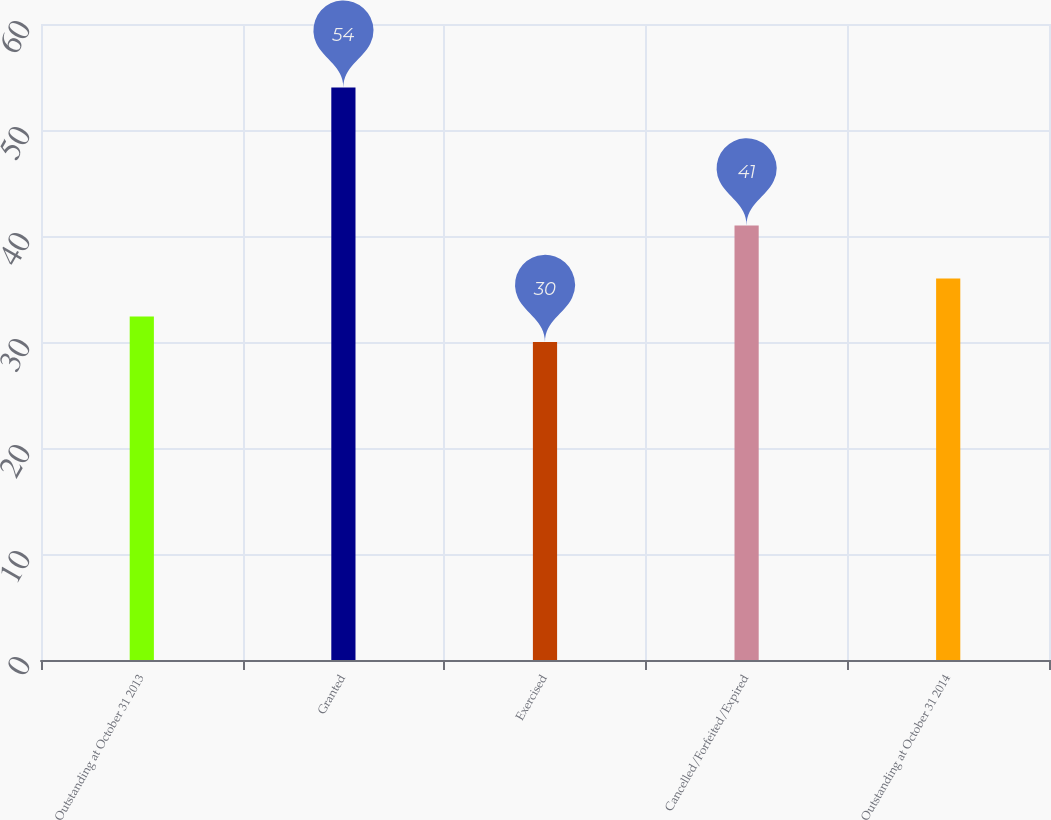Convert chart to OTSL. <chart><loc_0><loc_0><loc_500><loc_500><bar_chart><fcel>Outstanding at October 31 2013<fcel>Granted<fcel>Exercised<fcel>Cancelled/Forfeited/Expired<fcel>Outstanding at October 31 2014<nl><fcel>32.4<fcel>54<fcel>30<fcel>41<fcel>36<nl></chart> 